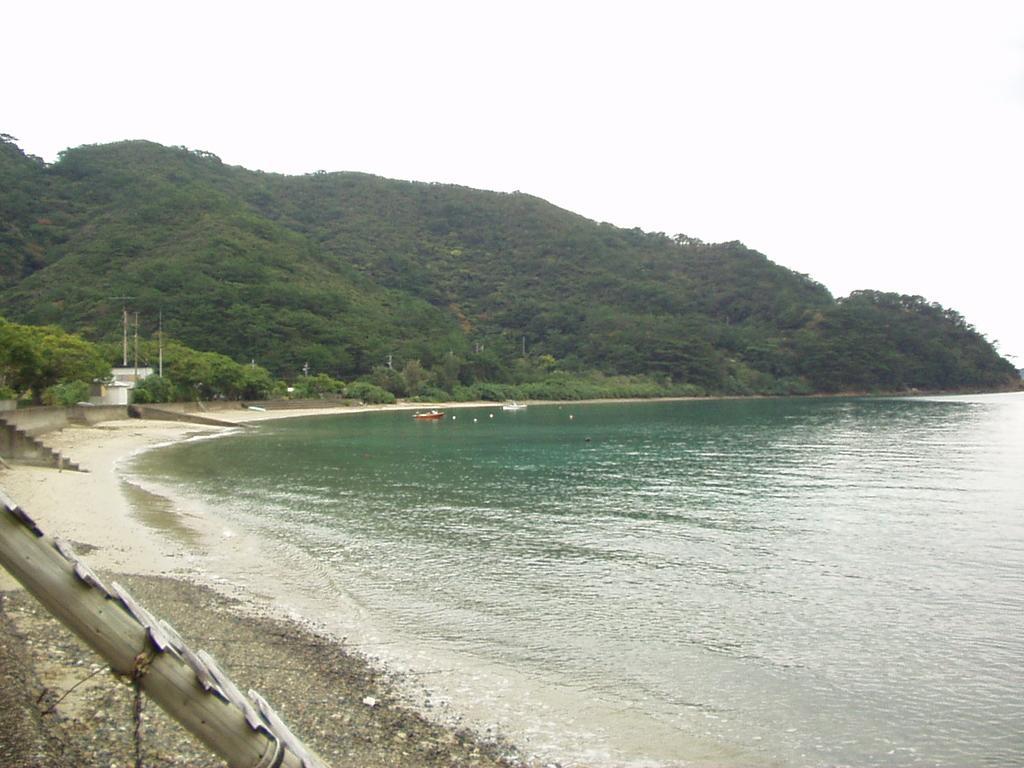In one or two sentences, can you explain what this image depicts? In the image we can see water and we can see there are even boats in the water. Here we can see plants, trees, the hill and the sky. Here we can see the stones, and sand a wooden ladder. 